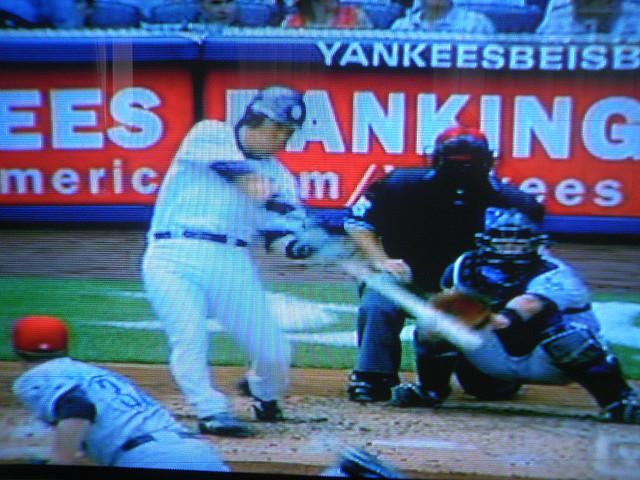Who is swinging the bat?
Keep it brief. Batter. According to the sign, what team is this?
Concise answer only. Yankees. What sport is this?
Short answer required. Baseball. 